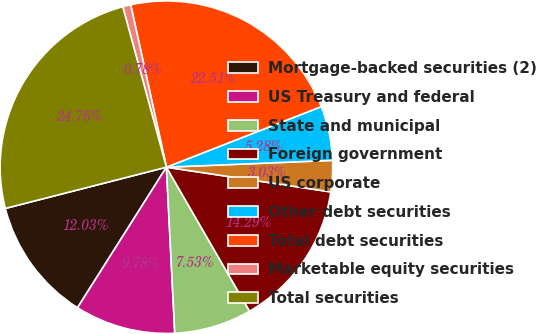Convert chart to OTSL. <chart><loc_0><loc_0><loc_500><loc_500><pie_chart><fcel>Mortgage-backed securities (2)<fcel>US Treasury and federal<fcel>State and municipal<fcel>Foreign government<fcel>US corporate<fcel>Other debt securities<fcel>Total debt securities<fcel>Marketable equity securities<fcel>Total securities<nl><fcel>12.03%<fcel>9.78%<fcel>7.53%<fcel>14.29%<fcel>3.03%<fcel>5.28%<fcel>22.51%<fcel>0.78%<fcel>24.76%<nl></chart> 